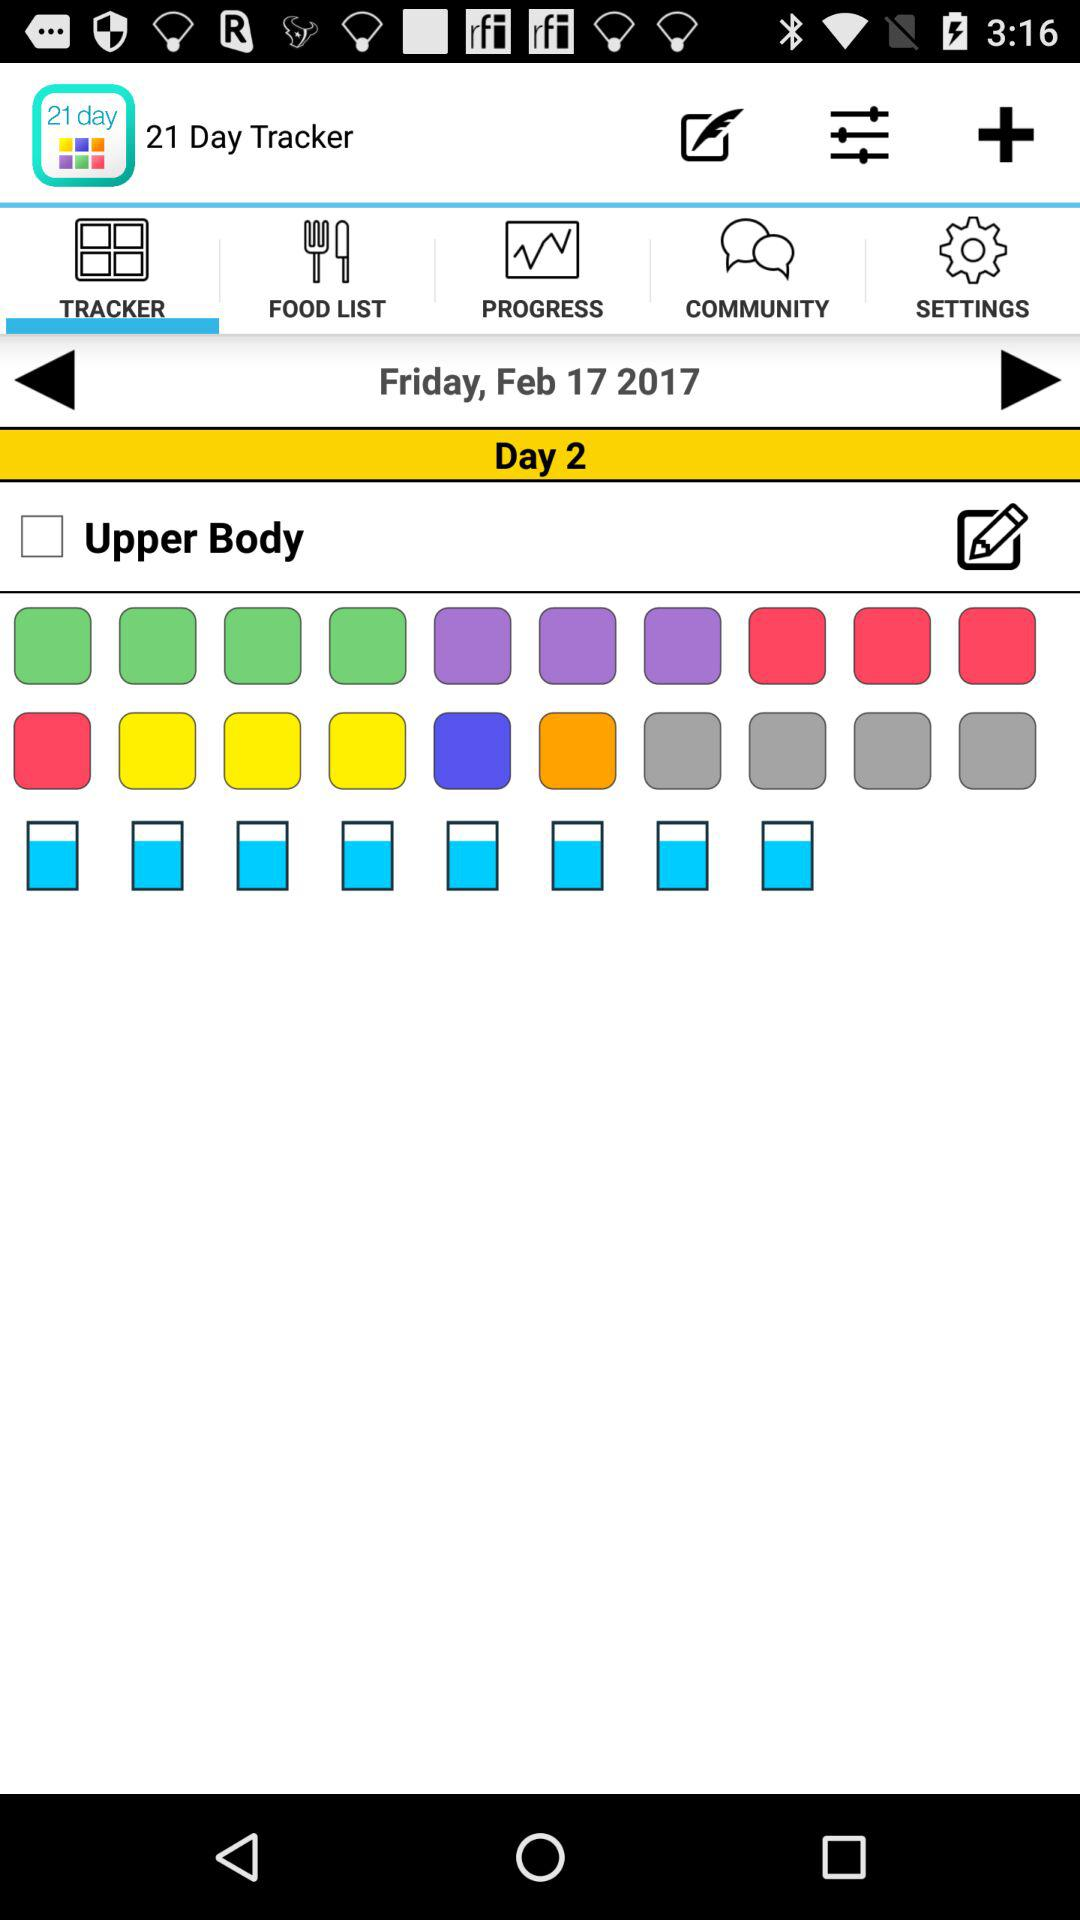What is the name of the application? The name of the application is "21 Day Tracker". 